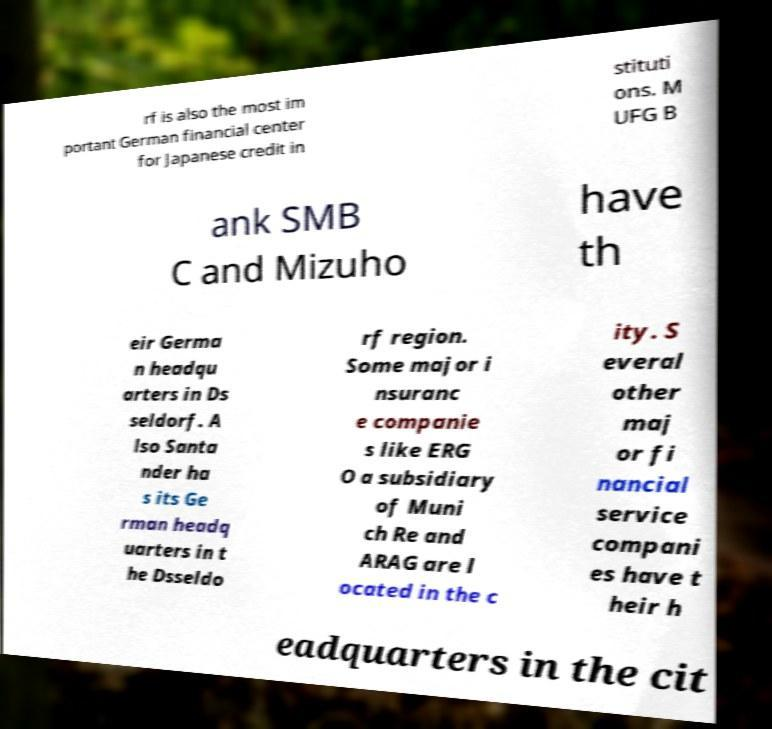Can you accurately transcribe the text from the provided image for me? rf is also the most im portant German financial center for Japanese credit in stituti ons. M UFG B ank SMB C and Mizuho have th eir Germa n headqu arters in Ds seldorf. A lso Santa nder ha s its Ge rman headq uarters in t he Dsseldo rf region. Some major i nsuranc e companie s like ERG O a subsidiary of Muni ch Re and ARAG are l ocated in the c ity. S everal other maj or fi nancial service compani es have t heir h eadquarters in the cit 